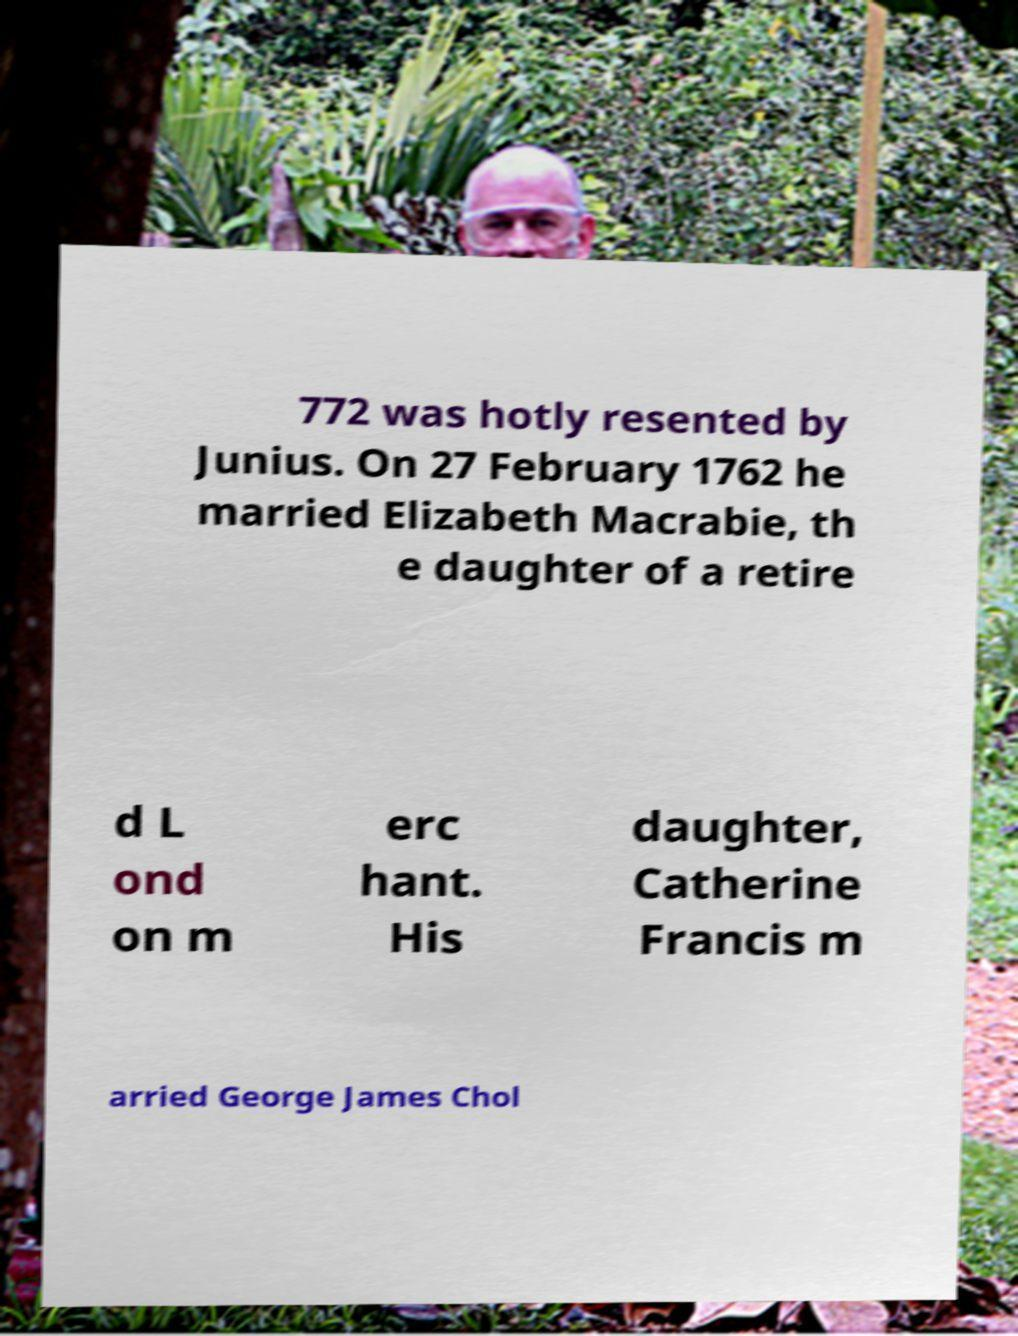I need the written content from this picture converted into text. Can you do that? 772 was hotly resented by Junius. On 27 February 1762 he married Elizabeth Macrabie, th e daughter of a retire d L ond on m erc hant. His daughter, Catherine Francis m arried George James Chol 